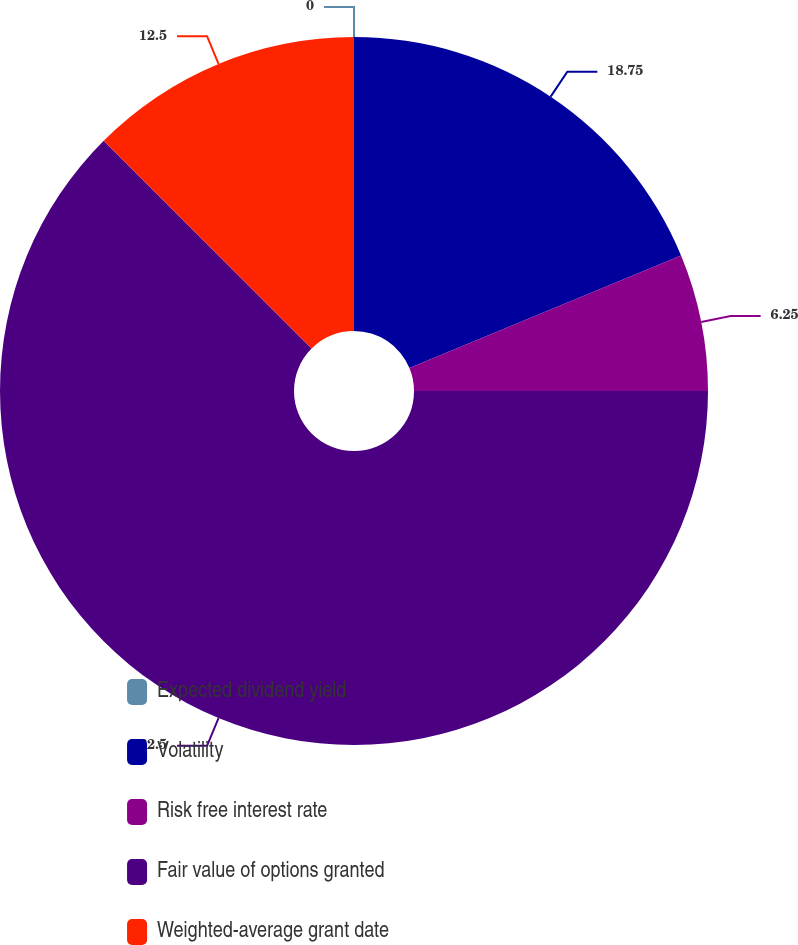<chart> <loc_0><loc_0><loc_500><loc_500><pie_chart><fcel>Expected dividend yield<fcel>Volatility<fcel>Risk free interest rate<fcel>Fair value of options granted<fcel>Weighted-average grant date<nl><fcel>0.0%<fcel>18.75%<fcel>6.25%<fcel>62.5%<fcel>12.5%<nl></chart> 